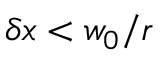<formula> <loc_0><loc_0><loc_500><loc_500>\delta x < w _ { 0 } / r</formula> 